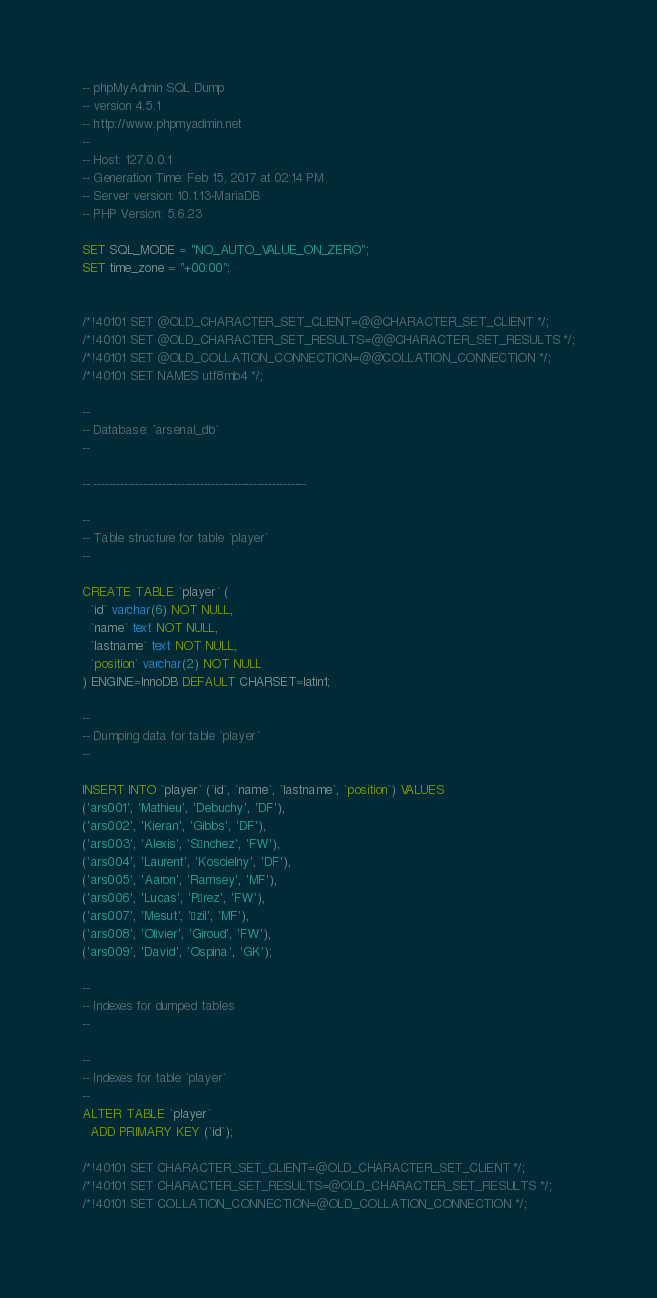<code> <loc_0><loc_0><loc_500><loc_500><_SQL_>-- phpMyAdmin SQL Dump
-- version 4.5.1
-- http://www.phpmyadmin.net
--
-- Host: 127.0.0.1
-- Generation Time: Feb 15, 2017 at 02:14 PM
-- Server version: 10.1.13-MariaDB
-- PHP Version: 5.6.23

SET SQL_MODE = "NO_AUTO_VALUE_ON_ZERO";
SET time_zone = "+00:00";


/*!40101 SET @OLD_CHARACTER_SET_CLIENT=@@CHARACTER_SET_CLIENT */;
/*!40101 SET @OLD_CHARACTER_SET_RESULTS=@@CHARACTER_SET_RESULTS */;
/*!40101 SET @OLD_COLLATION_CONNECTION=@@COLLATION_CONNECTION */;
/*!40101 SET NAMES utf8mb4 */;

--
-- Database: `arsenal_db`
--

-- --------------------------------------------------------

--
-- Table structure for table `player`
--

CREATE TABLE `player` (
  `id` varchar(6) NOT NULL,
  `name` text NOT NULL,
  `lastname` text NOT NULL,
  `position` varchar(2) NOT NULL
) ENGINE=InnoDB DEFAULT CHARSET=latin1;

--
-- Dumping data for table `player`
--

INSERT INTO `player` (`id`, `name`, `lastname`, `position`) VALUES
('ars001', 'Mathieu', 'Debuchy', 'DF'),
('ars002', 'Kieran', 'Gibbs', 'DF'),
('ars003', 'Alexis', 'Sánchez', 'FW'),
('ars004', 'Laurent', 'Koscielny', 'DF'),
('ars005', 'Aaron', 'Ramsey', 'MF'),
('ars006', 'Lucas', 'Pérez', 'FW'),
('ars007', 'Mesut', 'Özil', 'MF'),
('ars008', 'Olivier', 'Giroud', 'FW'),
('ars009', 'David', 'Ospina', 'GK');

--
-- Indexes for dumped tables
--

--
-- Indexes for table `player`
--
ALTER TABLE `player`
  ADD PRIMARY KEY (`id`);

/*!40101 SET CHARACTER_SET_CLIENT=@OLD_CHARACTER_SET_CLIENT */;
/*!40101 SET CHARACTER_SET_RESULTS=@OLD_CHARACTER_SET_RESULTS */;
/*!40101 SET COLLATION_CONNECTION=@OLD_COLLATION_CONNECTION */;
</code> 